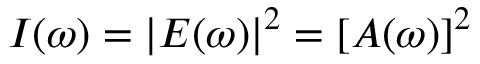<formula> <loc_0><loc_0><loc_500><loc_500>I ( \omega ) = | E ( \omega ) | ^ { 2 } = [ A ( \omega ) ] ^ { 2 }</formula> 